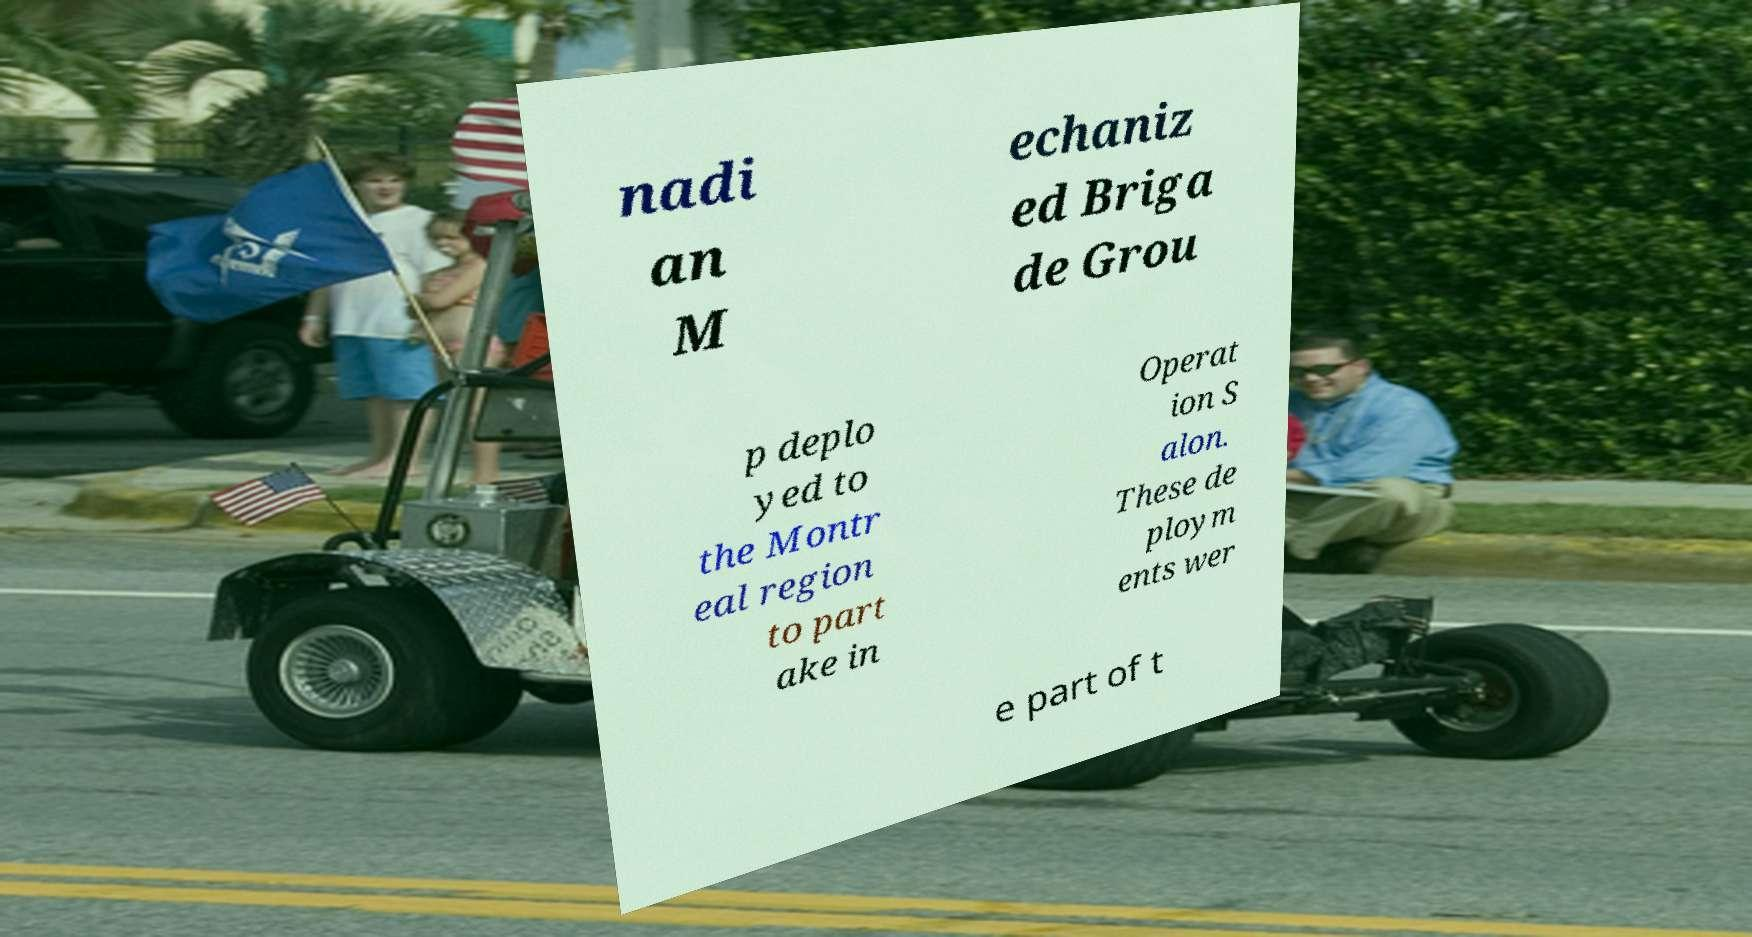What messages or text are displayed in this image? I need them in a readable, typed format. nadi an M echaniz ed Briga de Grou p deplo yed to the Montr eal region to part ake in Operat ion S alon. These de ploym ents wer e part of t 